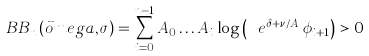Convert formula to latex. <formula><loc_0><loc_0><loc_500><loc_500>\ B B _ { n } ( \vec { o } m e g a , \sigma ) = \sum _ { i = 0 } ^ { n - 1 } A _ { 0 } \dots A _ { i } \log \left ( \ e ^ { \delta + \nu / A _ { i } } \phi _ { i + 1 } \right ) > 0</formula> 